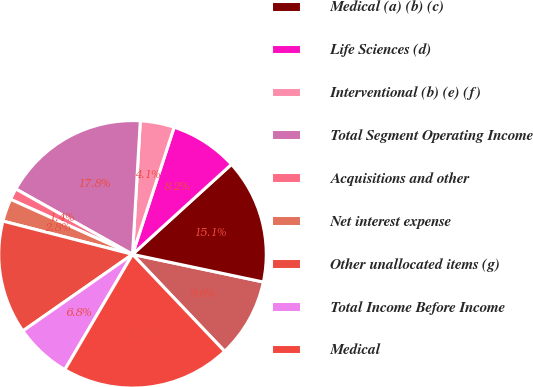<chart> <loc_0><loc_0><loc_500><loc_500><pie_chart><fcel>(Millions of dollars)<fcel>Medical (a) (b) (c)<fcel>Life Sciences (d)<fcel>Interventional (b) (e) (f)<fcel>Total Segment Operating Income<fcel>Acquisitions and other<fcel>Net interest expense<fcel>Other unallocated items (g)<fcel>Total Income Before Income<fcel>Medical<nl><fcel>9.59%<fcel>15.06%<fcel>8.22%<fcel>4.11%<fcel>17.8%<fcel>1.38%<fcel>2.75%<fcel>13.7%<fcel>6.85%<fcel>20.54%<nl></chart> 